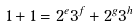Convert formula to latex. <formula><loc_0><loc_0><loc_500><loc_500>1 + 1 = 2 ^ { e } 3 ^ { f } + 2 ^ { g } 3 ^ { h }</formula> 